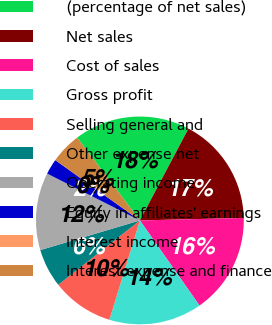Convert chart. <chart><loc_0><loc_0><loc_500><loc_500><pie_chart><fcel>(percentage of net sales)<fcel>Net sales<fcel>Cost of sales<fcel>Gross profit<fcel>Selling general and<fcel>Other expense net<fcel>Operating income<fcel>Equity in affiliates' earnings<fcel>Interest income<fcel>Interest expense and finance<nl><fcel>18.07%<fcel>16.87%<fcel>15.66%<fcel>14.46%<fcel>9.64%<fcel>6.02%<fcel>12.05%<fcel>2.41%<fcel>0.0%<fcel>4.82%<nl></chart> 